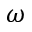Convert formula to latex. <formula><loc_0><loc_0><loc_500><loc_500>\omega</formula> 